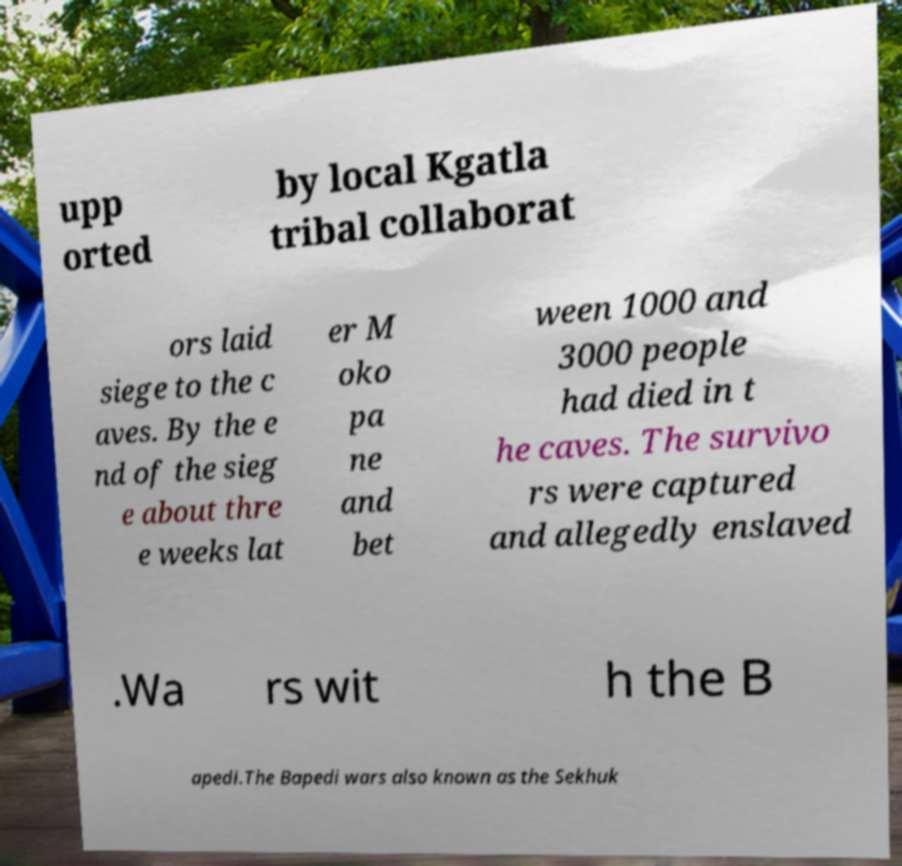Could you extract and type out the text from this image? upp orted by local Kgatla tribal collaborat ors laid siege to the c aves. By the e nd of the sieg e about thre e weeks lat er M oko pa ne and bet ween 1000 and 3000 people had died in t he caves. The survivo rs were captured and allegedly enslaved .Wa rs wit h the B apedi.The Bapedi wars also known as the Sekhuk 